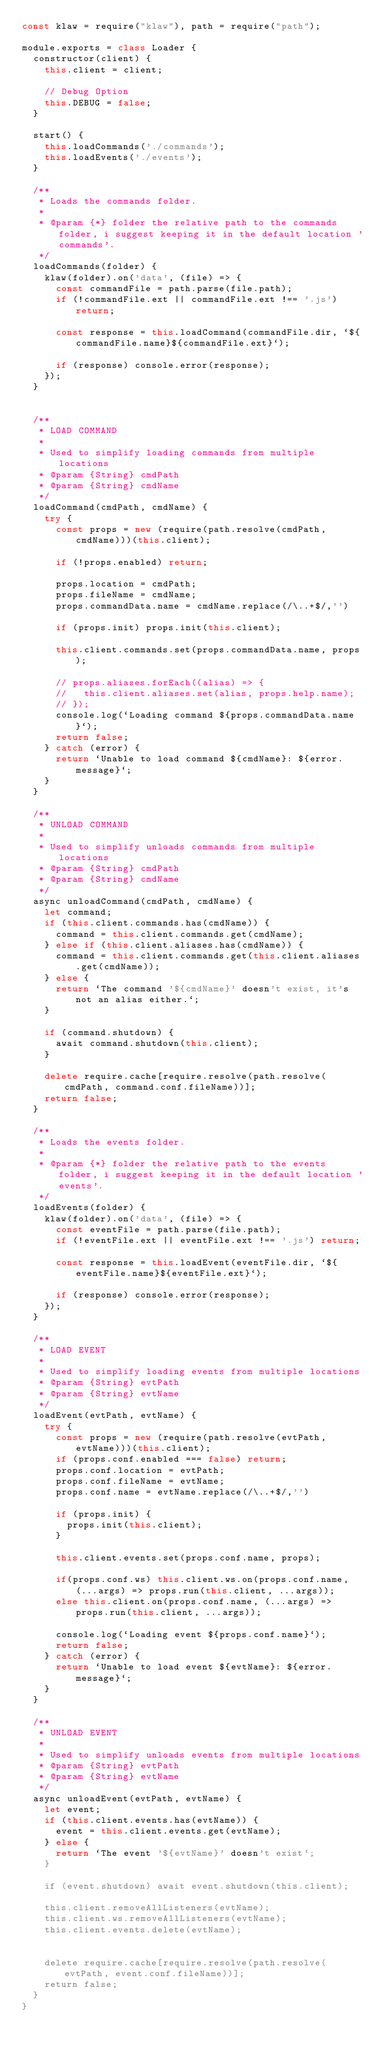Convert code to text. <code><loc_0><loc_0><loc_500><loc_500><_JavaScript_>const klaw = require("klaw"), path = require("path");

module.exports = class Loader {
  constructor(client) {
    this.client = client;

    // Debug Option
    this.DEBUG = false;
  }

  start() {
    this.loadCommands('./commands');
    this.loadEvents('./events');
  }

  /**
   * Loads the commands folder.
   *
   * @param {*} folder the relative path to the commands folder, i suggest keeping it in the default location 'commands'.
   */
  loadCommands(folder) {
    klaw(folder).on('data', (file) => {
      const commandFile = path.parse(file.path);
      if (!commandFile.ext || commandFile.ext !== '.js') return;

      const response = this.loadCommand(commandFile.dir, `${commandFile.name}${commandFile.ext}`);

      if (response) console.error(response);
    });
  }


  /**
   * LOAD COMMAND
   *
   * Used to simplify loading commands from multiple locations
   * @param {String} cmdPath
   * @param {String} cmdName
   */
  loadCommand(cmdPath, cmdName) {
    try {
      const props = new (require(path.resolve(cmdPath, cmdName)))(this.client);

      if (!props.enabled) return;

      props.location = cmdPath;
      props.fileName = cmdName;
      props.commandData.name = cmdName.replace(/\..+$/,'')

      if (props.init) props.init(this.client);

      this.client.commands.set(props.commandData.name, props);

      // props.aliases.forEach((alias) => {
      //   this.client.aliases.set(alias, props.help.name);
      // });
      console.log(`Loading command ${props.commandData.name}`);
      return false;
    } catch (error) {
      return `Unable to load command ${cmdName}: ${error.message}`;
    }
  }

  /**
   * UNLOAD COMMAND
   *
   * Used to simplify unloads commands from multiple locations
   * @param {String} cmdPath
   * @param {String} cmdName
   */
  async unloadCommand(cmdPath, cmdName) {
    let command;
    if (this.client.commands.has(cmdName)) {
      command = this.client.commands.get(cmdName);
    } else if (this.client.aliases.has(cmdName)) {
      command = this.client.commands.get(this.client.aliases.get(cmdName));
    } else {
      return `The command '${cmdName}' doesn't exist, it's not an alias either.`;
    }

    if (command.shutdown) {
      await command.shutdown(this.client);
    }

    delete require.cache[require.resolve(path.resolve(cmdPath, command.conf.fileName))];
    return false;
  }

  /**
   * Loads the events folder.
   *
   * @param {*} folder the relative path to the events folder, i suggest keeping it in the default location 'events'.
   */
  loadEvents(folder) {
    klaw(folder).on('data', (file) => {
      const eventFile = path.parse(file.path);
      if (!eventFile.ext || eventFile.ext !== '.js') return;

      const response = this.loadEvent(eventFile.dir, `${eventFile.name}${eventFile.ext}`);

      if (response) console.error(response);
    });
  }

  /**
   * LOAD EVENT
   *
   * Used to simplify loading events from multiple locations
   * @param {String} evtPath
   * @param {String} evtName
   */
  loadEvent(evtPath, evtName) {
    try {
      const props = new (require(path.resolve(evtPath, evtName)))(this.client);
      if (props.conf.enabled === false) return;
      props.conf.location = evtPath;
      props.conf.fileName = evtName;
      props.conf.name = evtName.replace(/\..+$/,'')

      if (props.init) {
        props.init(this.client);
      }
      
      this.client.events.set(props.conf.name, props);
      
      if(props.conf.ws) this.client.ws.on(props.conf.name, (...args) => props.run(this.client, ...args));
      else this.client.on(props.conf.name, (...args) => props.run(this.client, ...args));

      console.log(`Loading event ${props.conf.name}`);
      return false;
    } catch (error) {
      return `Unable to load event ${evtName}: ${error.message}`;
    }
  }

  /**
   * UNLOAD EVENT
   *
   * Used to simplify unloads events from multiple locations
   * @param {String} evtPath
   * @param {String} evtName
   */
  async unloadEvent(evtPath, evtName) {
    let event;
    if (this.client.events.has(evtName)) {
      event = this.client.events.get(evtName);
    } else {
      return `The event '${evtName}' doesn't exist`;
    }

    if (event.shutdown) await event.shutdown(this.client);
    
    this.client.removeAllListeners(evtName);
    this.client.ws.removeAllListeners(evtName);
    this.client.events.delete(evtName);
    

    delete require.cache[require.resolve(path.resolve(evtPath, event.conf.fileName))];
    return false;
  }
}</code> 